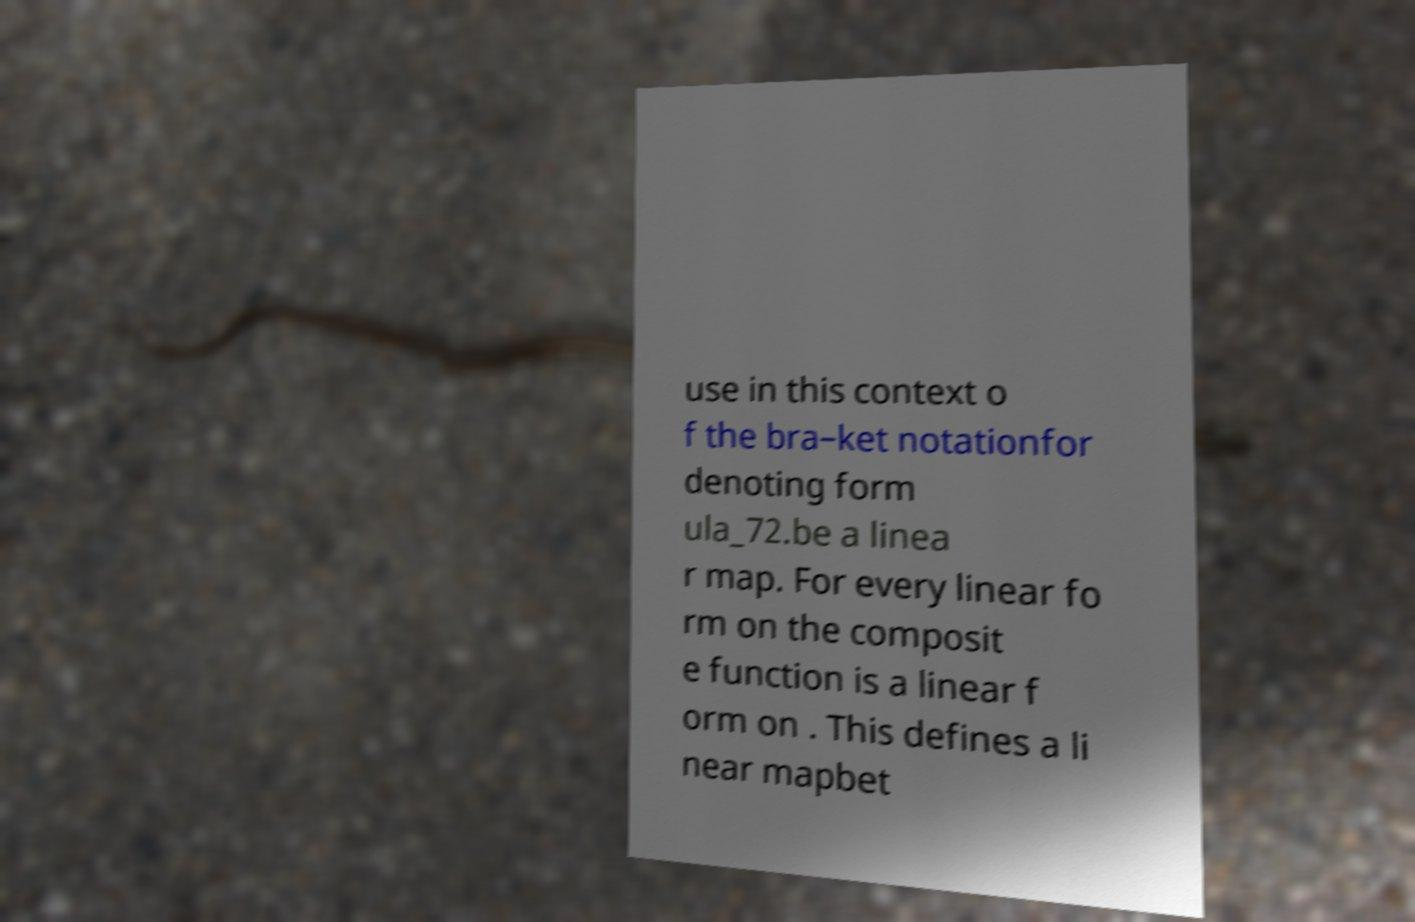Please identify and transcribe the text found in this image. use in this context o f the bra–ket notationfor denoting form ula_72.be a linea r map. For every linear fo rm on the composit e function is a linear f orm on . This defines a li near mapbet 